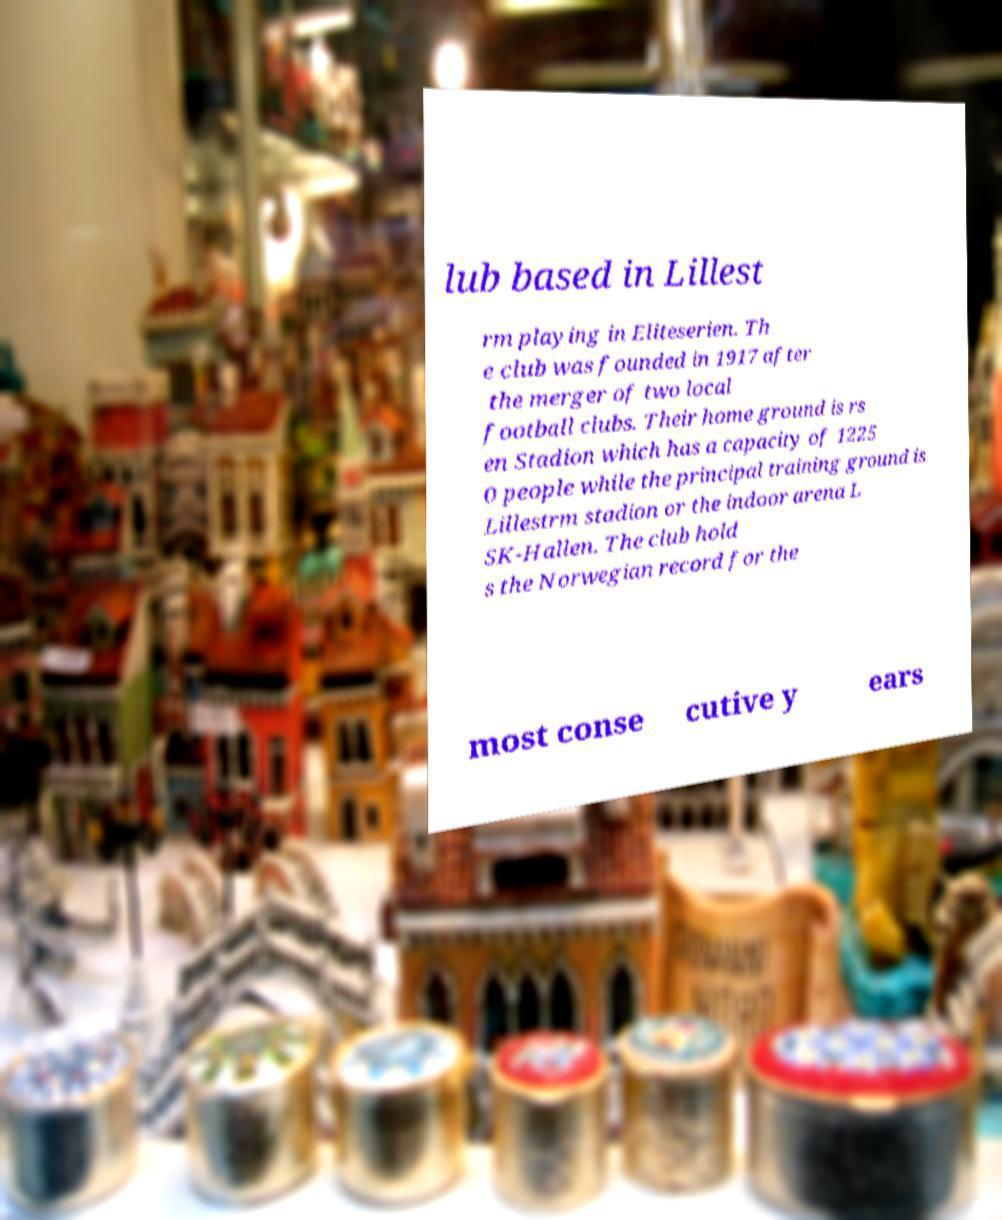Can you accurately transcribe the text from the provided image for me? lub based in Lillest rm playing in Eliteserien. Th e club was founded in 1917 after the merger of two local football clubs. Their home ground is rs en Stadion which has a capacity of 1225 0 people while the principal training ground is Lillestrm stadion or the indoor arena L SK-Hallen. The club hold s the Norwegian record for the most conse cutive y ears 